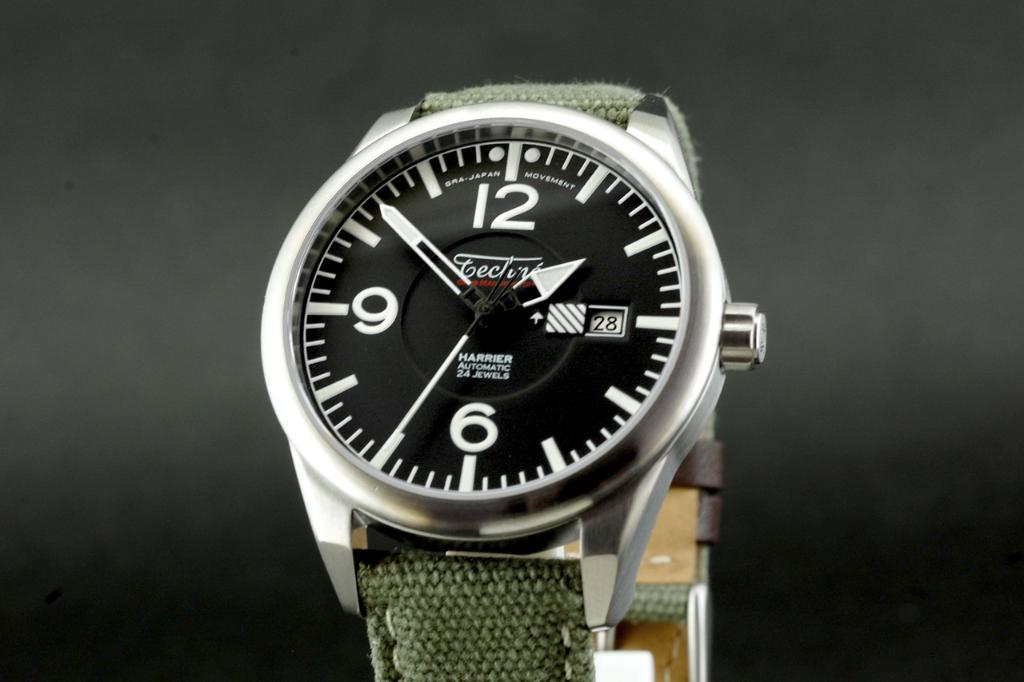<image>
Write a terse but informative summary of the picture. A watch face states that it is automatic and has 24 jewels. 